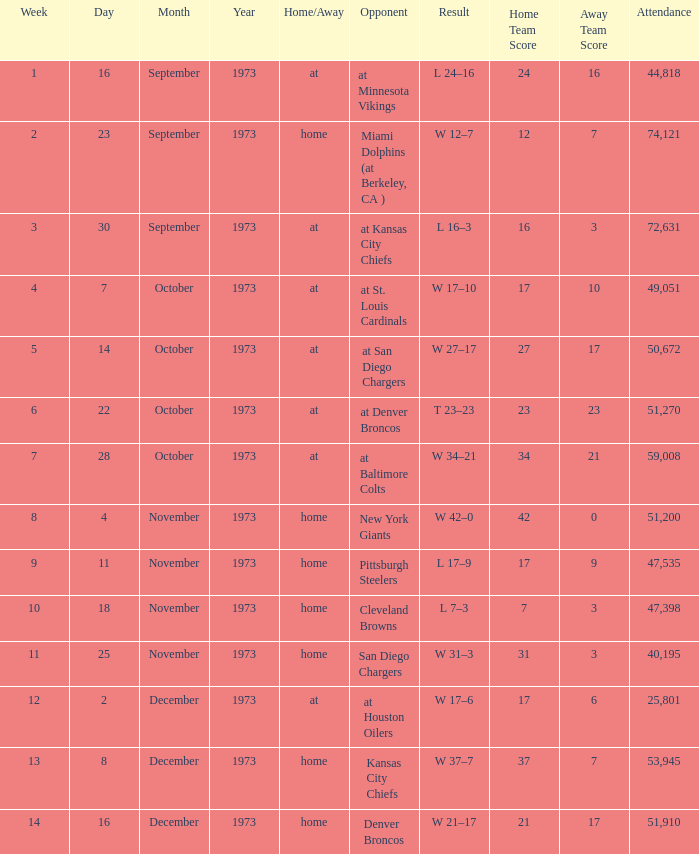What is the attendance for the game against the Kansas City Chiefs earlier than week 13? None. 